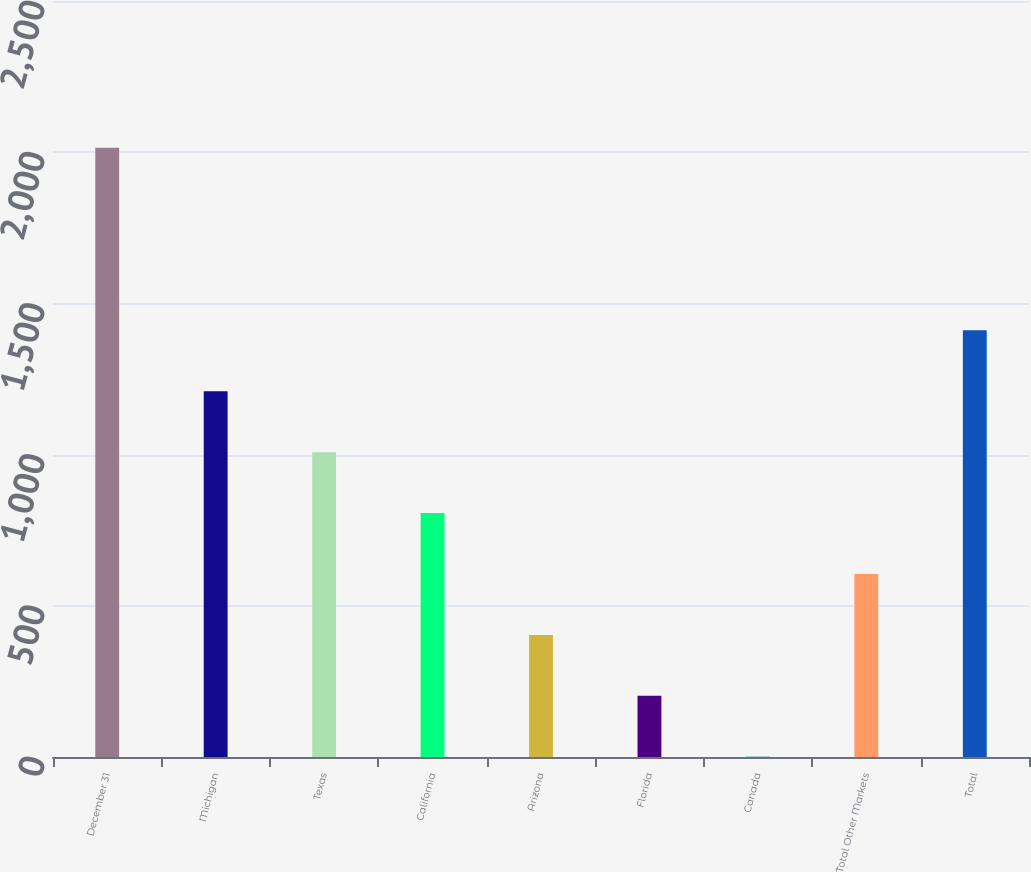Convert chart. <chart><loc_0><loc_0><loc_500><loc_500><bar_chart><fcel>December 31<fcel>Michigan<fcel>Texas<fcel>California<fcel>Arizona<fcel>Florida<fcel>Canada<fcel>Total Other Markets<fcel>Total<nl><fcel>2015<fcel>1209.4<fcel>1008<fcel>806.6<fcel>403.8<fcel>202.4<fcel>1<fcel>605.2<fcel>1410.8<nl></chart> 